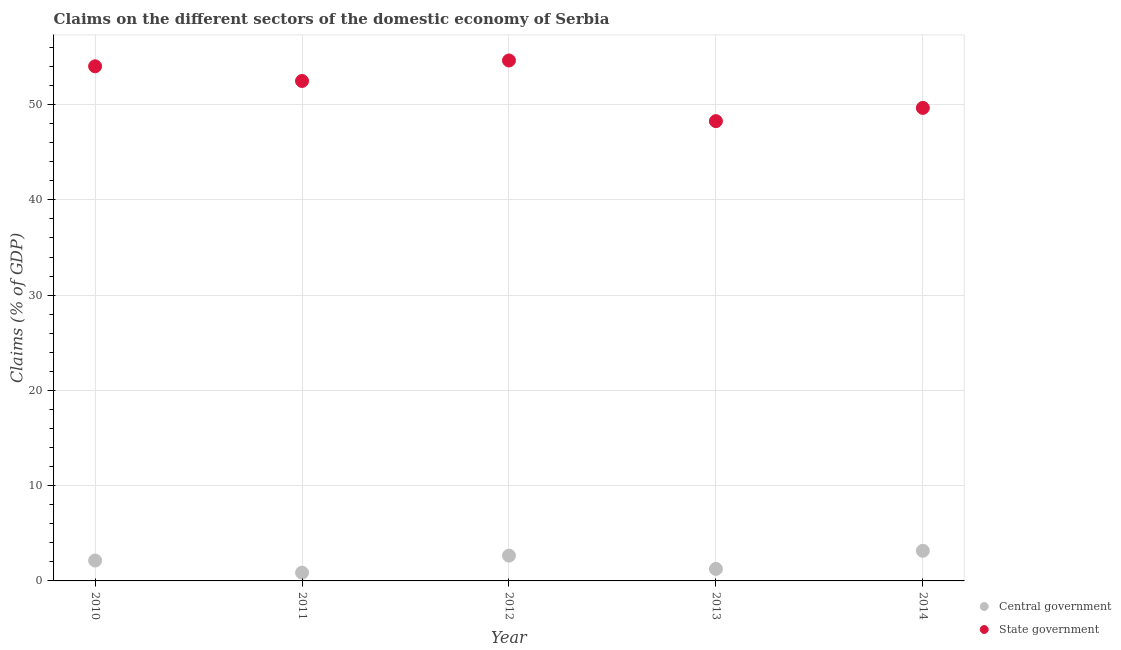How many different coloured dotlines are there?
Ensure brevity in your answer.  2. What is the claims on state government in 2014?
Offer a very short reply. 49.65. Across all years, what is the maximum claims on state government?
Give a very brief answer. 54.63. Across all years, what is the minimum claims on state government?
Offer a terse response. 48.26. In which year was the claims on state government maximum?
Keep it short and to the point. 2012. In which year was the claims on central government minimum?
Your answer should be very brief. 2011. What is the total claims on central government in the graph?
Ensure brevity in your answer.  10.08. What is the difference between the claims on central government in 2013 and that in 2014?
Give a very brief answer. -1.9. What is the difference between the claims on central government in 2011 and the claims on state government in 2012?
Provide a short and direct response. -53.76. What is the average claims on central government per year?
Provide a short and direct response. 2.02. In the year 2010, what is the difference between the claims on central government and claims on state government?
Give a very brief answer. -51.88. What is the ratio of the claims on central government in 2011 to that in 2013?
Offer a very short reply. 0.69. Is the difference between the claims on state government in 2011 and 2013 greater than the difference between the claims on central government in 2011 and 2013?
Provide a short and direct response. Yes. What is the difference between the highest and the second highest claims on central government?
Your answer should be compact. 0.51. What is the difference between the highest and the lowest claims on state government?
Your answer should be very brief. 6.37. Is the sum of the claims on state government in 2011 and 2014 greater than the maximum claims on central government across all years?
Make the answer very short. Yes. Does the claims on state government monotonically increase over the years?
Your response must be concise. No. Is the claims on state government strictly greater than the claims on central government over the years?
Make the answer very short. Yes. How many dotlines are there?
Provide a short and direct response. 2. What is the difference between two consecutive major ticks on the Y-axis?
Give a very brief answer. 10. Are the values on the major ticks of Y-axis written in scientific E-notation?
Provide a short and direct response. No. Where does the legend appear in the graph?
Offer a terse response. Bottom right. What is the title of the graph?
Provide a short and direct response. Claims on the different sectors of the domestic economy of Serbia. Does "Quality of trade" appear as one of the legend labels in the graph?
Give a very brief answer. No. What is the label or title of the X-axis?
Give a very brief answer. Year. What is the label or title of the Y-axis?
Ensure brevity in your answer.  Claims (% of GDP). What is the Claims (% of GDP) of Central government in 2010?
Give a very brief answer. 2.14. What is the Claims (% of GDP) in State government in 2010?
Give a very brief answer. 54.02. What is the Claims (% of GDP) of Central government in 2011?
Provide a succinct answer. 0.87. What is the Claims (% of GDP) of State government in 2011?
Your answer should be very brief. 52.48. What is the Claims (% of GDP) of Central government in 2012?
Ensure brevity in your answer.  2.65. What is the Claims (% of GDP) of State government in 2012?
Your response must be concise. 54.63. What is the Claims (% of GDP) of Central government in 2013?
Give a very brief answer. 1.26. What is the Claims (% of GDP) of State government in 2013?
Ensure brevity in your answer.  48.26. What is the Claims (% of GDP) of Central government in 2014?
Ensure brevity in your answer.  3.16. What is the Claims (% of GDP) of State government in 2014?
Keep it short and to the point. 49.65. Across all years, what is the maximum Claims (% of GDP) in Central government?
Your response must be concise. 3.16. Across all years, what is the maximum Claims (% of GDP) in State government?
Give a very brief answer. 54.63. Across all years, what is the minimum Claims (% of GDP) of Central government?
Offer a terse response. 0.87. Across all years, what is the minimum Claims (% of GDP) in State government?
Give a very brief answer. 48.26. What is the total Claims (% of GDP) in Central government in the graph?
Offer a terse response. 10.08. What is the total Claims (% of GDP) in State government in the graph?
Your answer should be compact. 259.05. What is the difference between the Claims (% of GDP) in Central government in 2010 and that in 2011?
Make the answer very short. 1.27. What is the difference between the Claims (% of GDP) of State government in 2010 and that in 2011?
Your answer should be very brief. 1.54. What is the difference between the Claims (% of GDP) in Central government in 2010 and that in 2012?
Give a very brief answer. -0.51. What is the difference between the Claims (% of GDP) in State government in 2010 and that in 2012?
Your answer should be compact. -0.61. What is the difference between the Claims (% of GDP) of Central government in 2010 and that in 2013?
Provide a short and direct response. 0.88. What is the difference between the Claims (% of GDP) of State government in 2010 and that in 2013?
Provide a succinct answer. 5.76. What is the difference between the Claims (% of GDP) of Central government in 2010 and that in 2014?
Keep it short and to the point. -1.02. What is the difference between the Claims (% of GDP) in State government in 2010 and that in 2014?
Offer a terse response. 4.37. What is the difference between the Claims (% of GDP) in Central government in 2011 and that in 2012?
Ensure brevity in your answer.  -1.79. What is the difference between the Claims (% of GDP) of State government in 2011 and that in 2012?
Offer a very short reply. -2.15. What is the difference between the Claims (% of GDP) of Central government in 2011 and that in 2013?
Offer a very short reply. -0.39. What is the difference between the Claims (% of GDP) of State government in 2011 and that in 2013?
Ensure brevity in your answer.  4.22. What is the difference between the Claims (% of GDP) in Central government in 2011 and that in 2014?
Offer a very short reply. -2.3. What is the difference between the Claims (% of GDP) of State government in 2011 and that in 2014?
Keep it short and to the point. 2.83. What is the difference between the Claims (% of GDP) in Central government in 2012 and that in 2013?
Offer a very short reply. 1.39. What is the difference between the Claims (% of GDP) of State government in 2012 and that in 2013?
Offer a terse response. 6.37. What is the difference between the Claims (% of GDP) in Central government in 2012 and that in 2014?
Offer a very short reply. -0.51. What is the difference between the Claims (% of GDP) in State government in 2012 and that in 2014?
Offer a terse response. 4.98. What is the difference between the Claims (% of GDP) in Central government in 2013 and that in 2014?
Your answer should be very brief. -1.9. What is the difference between the Claims (% of GDP) in State government in 2013 and that in 2014?
Give a very brief answer. -1.39. What is the difference between the Claims (% of GDP) of Central government in 2010 and the Claims (% of GDP) of State government in 2011?
Keep it short and to the point. -50.34. What is the difference between the Claims (% of GDP) of Central government in 2010 and the Claims (% of GDP) of State government in 2012?
Provide a succinct answer. -52.49. What is the difference between the Claims (% of GDP) in Central government in 2010 and the Claims (% of GDP) in State government in 2013?
Give a very brief answer. -46.12. What is the difference between the Claims (% of GDP) in Central government in 2010 and the Claims (% of GDP) in State government in 2014?
Give a very brief answer. -47.51. What is the difference between the Claims (% of GDP) in Central government in 2011 and the Claims (% of GDP) in State government in 2012?
Provide a succinct answer. -53.76. What is the difference between the Claims (% of GDP) in Central government in 2011 and the Claims (% of GDP) in State government in 2013?
Your answer should be very brief. -47.4. What is the difference between the Claims (% of GDP) of Central government in 2011 and the Claims (% of GDP) of State government in 2014?
Your response must be concise. -48.79. What is the difference between the Claims (% of GDP) in Central government in 2012 and the Claims (% of GDP) in State government in 2013?
Give a very brief answer. -45.61. What is the difference between the Claims (% of GDP) of Central government in 2012 and the Claims (% of GDP) of State government in 2014?
Offer a very short reply. -47. What is the difference between the Claims (% of GDP) of Central government in 2013 and the Claims (% of GDP) of State government in 2014?
Your answer should be very brief. -48.39. What is the average Claims (% of GDP) of Central government per year?
Give a very brief answer. 2.02. What is the average Claims (% of GDP) in State government per year?
Keep it short and to the point. 51.81. In the year 2010, what is the difference between the Claims (% of GDP) of Central government and Claims (% of GDP) of State government?
Your response must be concise. -51.88. In the year 2011, what is the difference between the Claims (% of GDP) in Central government and Claims (% of GDP) in State government?
Your response must be concise. -51.61. In the year 2012, what is the difference between the Claims (% of GDP) in Central government and Claims (% of GDP) in State government?
Your answer should be very brief. -51.98. In the year 2013, what is the difference between the Claims (% of GDP) in Central government and Claims (% of GDP) in State government?
Give a very brief answer. -47. In the year 2014, what is the difference between the Claims (% of GDP) in Central government and Claims (% of GDP) in State government?
Your answer should be very brief. -46.49. What is the ratio of the Claims (% of GDP) in Central government in 2010 to that in 2011?
Your answer should be very brief. 2.47. What is the ratio of the Claims (% of GDP) of State government in 2010 to that in 2011?
Provide a succinct answer. 1.03. What is the ratio of the Claims (% of GDP) of Central government in 2010 to that in 2012?
Your response must be concise. 0.81. What is the ratio of the Claims (% of GDP) in Central government in 2010 to that in 2013?
Keep it short and to the point. 1.7. What is the ratio of the Claims (% of GDP) in State government in 2010 to that in 2013?
Provide a succinct answer. 1.12. What is the ratio of the Claims (% of GDP) in Central government in 2010 to that in 2014?
Provide a short and direct response. 0.68. What is the ratio of the Claims (% of GDP) in State government in 2010 to that in 2014?
Provide a succinct answer. 1.09. What is the ratio of the Claims (% of GDP) of Central government in 2011 to that in 2012?
Provide a short and direct response. 0.33. What is the ratio of the Claims (% of GDP) in State government in 2011 to that in 2012?
Your answer should be very brief. 0.96. What is the ratio of the Claims (% of GDP) of Central government in 2011 to that in 2013?
Offer a very short reply. 0.69. What is the ratio of the Claims (% of GDP) in State government in 2011 to that in 2013?
Offer a very short reply. 1.09. What is the ratio of the Claims (% of GDP) of Central government in 2011 to that in 2014?
Provide a short and direct response. 0.27. What is the ratio of the Claims (% of GDP) of State government in 2011 to that in 2014?
Give a very brief answer. 1.06. What is the ratio of the Claims (% of GDP) of Central government in 2012 to that in 2013?
Make the answer very short. 2.1. What is the ratio of the Claims (% of GDP) of State government in 2012 to that in 2013?
Your response must be concise. 1.13. What is the ratio of the Claims (% of GDP) of Central government in 2012 to that in 2014?
Provide a short and direct response. 0.84. What is the ratio of the Claims (% of GDP) in State government in 2012 to that in 2014?
Provide a succinct answer. 1.1. What is the ratio of the Claims (% of GDP) in Central government in 2013 to that in 2014?
Ensure brevity in your answer.  0.4. What is the difference between the highest and the second highest Claims (% of GDP) in Central government?
Keep it short and to the point. 0.51. What is the difference between the highest and the second highest Claims (% of GDP) in State government?
Offer a terse response. 0.61. What is the difference between the highest and the lowest Claims (% of GDP) of Central government?
Your response must be concise. 2.3. What is the difference between the highest and the lowest Claims (% of GDP) of State government?
Your answer should be compact. 6.37. 